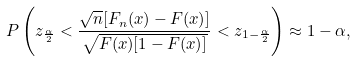<formula> <loc_0><loc_0><loc_500><loc_500>P \left ( z _ { \frac { \alpha } { 2 } } < \frac { \sqrt { n } [ F _ { n } ( x ) - F ( x ) ] } { \sqrt { F ( x ) [ 1 - F ( x ) ] } } < z _ { 1 - \frac { \alpha } { 2 } } \right ) \approx 1 - \alpha ,</formula> 